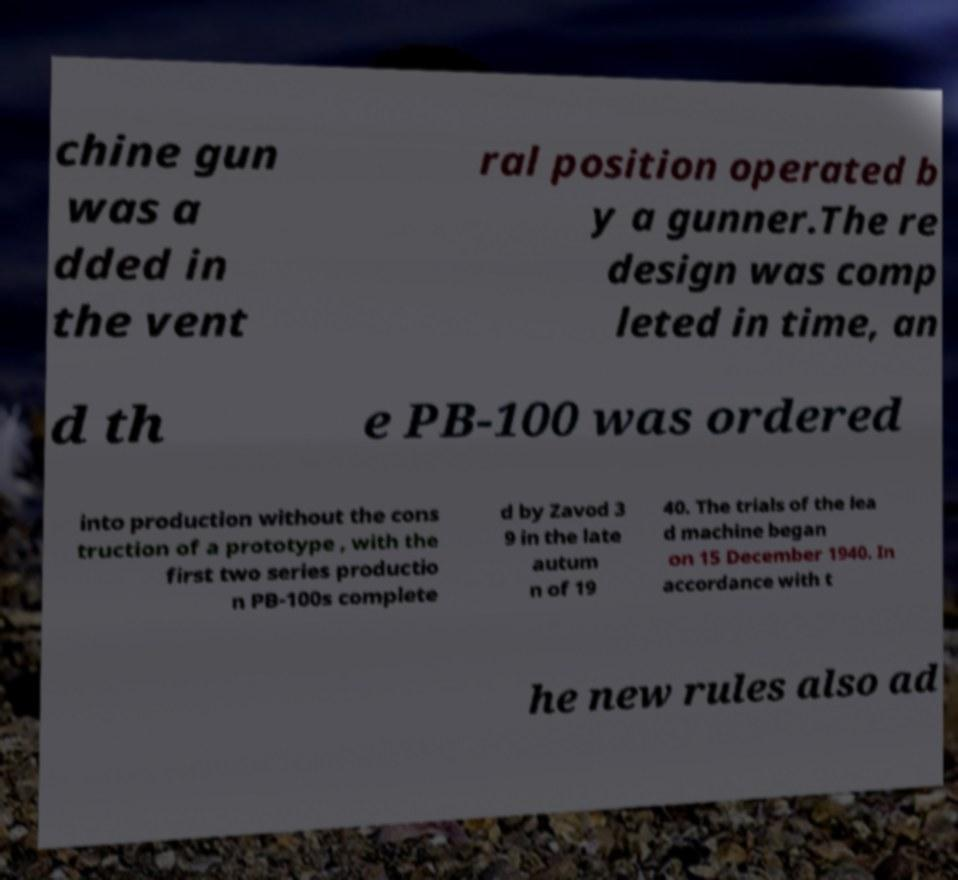I need the written content from this picture converted into text. Can you do that? chine gun was a dded in the vent ral position operated b y a gunner.The re design was comp leted in time, an d th e PB-100 was ordered into production without the cons truction of a prototype , with the first two series productio n PB-100s complete d by Zavod 3 9 in the late autum n of 19 40. The trials of the lea d machine began on 15 December 1940. In accordance with t he new rules also ad 